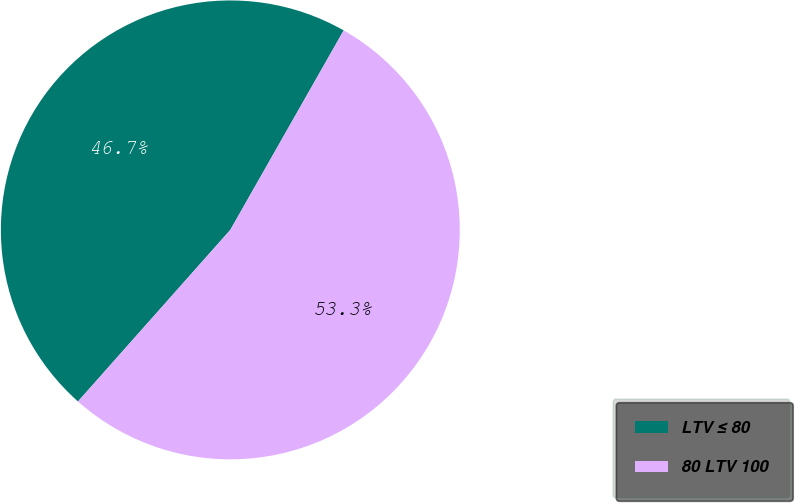Convert chart. <chart><loc_0><loc_0><loc_500><loc_500><pie_chart><fcel>LTV ≤ 80<fcel>80 LTV 100<nl><fcel>46.67%<fcel>53.33%<nl></chart> 